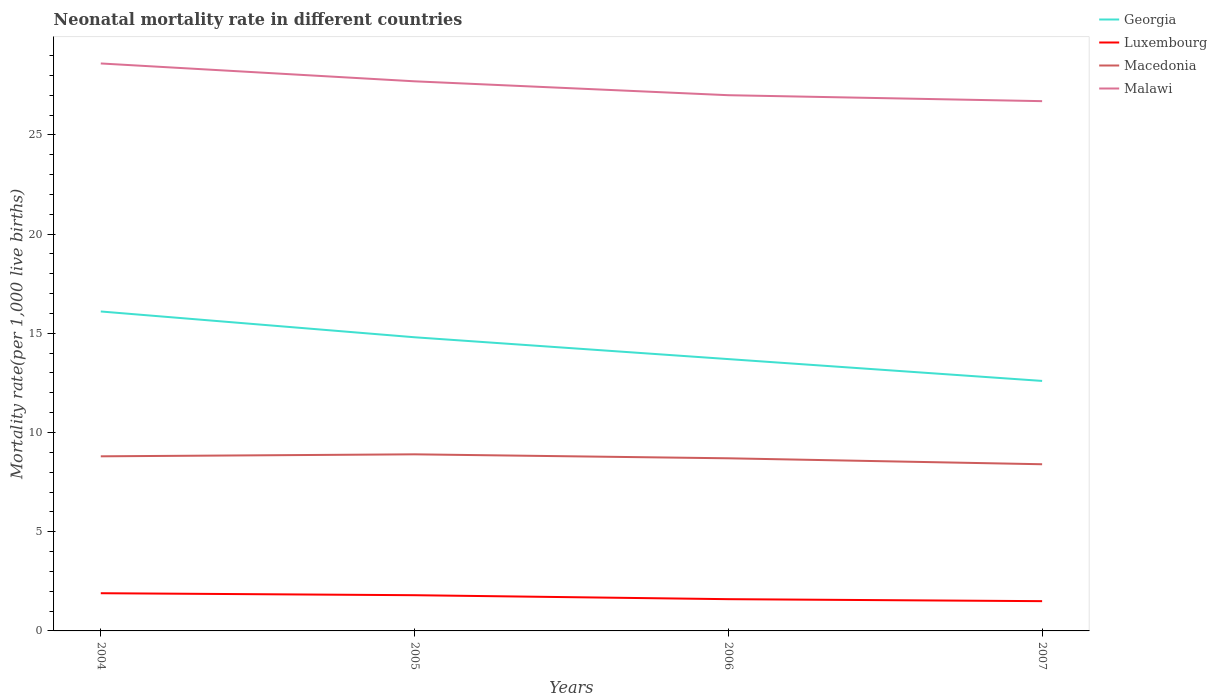Does the line corresponding to Georgia intersect with the line corresponding to Macedonia?
Offer a terse response. No. Across all years, what is the maximum neonatal mortality rate in Macedonia?
Offer a terse response. 8.4. What is the total neonatal mortality rate in Luxembourg in the graph?
Offer a terse response. 0.3. What is the difference between the highest and the second highest neonatal mortality rate in Georgia?
Give a very brief answer. 3.5. Is the neonatal mortality rate in Malawi strictly greater than the neonatal mortality rate in Georgia over the years?
Make the answer very short. No. How many lines are there?
Keep it short and to the point. 4. How many years are there in the graph?
Make the answer very short. 4. What is the difference between two consecutive major ticks on the Y-axis?
Your response must be concise. 5. Are the values on the major ticks of Y-axis written in scientific E-notation?
Your answer should be compact. No. How many legend labels are there?
Your answer should be very brief. 4. How are the legend labels stacked?
Your answer should be compact. Vertical. What is the title of the graph?
Your response must be concise. Neonatal mortality rate in different countries. Does "Rwanda" appear as one of the legend labels in the graph?
Offer a very short reply. No. What is the label or title of the Y-axis?
Your response must be concise. Mortality rate(per 1,0 live births). What is the Mortality rate(per 1,000 live births) in Luxembourg in 2004?
Ensure brevity in your answer.  1.9. What is the Mortality rate(per 1,000 live births) of Macedonia in 2004?
Give a very brief answer. 8.8. What is the Mortality rate(per 1,000 live births) in Malawi in 2004?
Your response must be concise. 28.6. What is the Mortality rate(per 1,000 live births) of Georgia in 2005?
Offer a terse response. 14.8. What is the Mortality rate(per 1,000 live births) in Malawi in 2005?
Keep it short and to the point. 27.7. What is the Mortality rate(per 1,000 live births) of Macedonia in 2006?
Your answer should be very brief. 8.7. What is the Mortality rate(per 1,000 live births) in Luxembourg in 2007?
Your response must be concise. 1.5. What is the Mortality rate(per 1,000 live births) in Macedonia in 2007?
Offer a very short reply. 8.4. What is the Mortality rate(per 1,000 live births) in Malawi in 2007?
Your answer should be very brief. 26.7. Across all years, what is the maximum Mortality rate(per 1,000 live births) in Luxembourg?
Offer a very short reply. 1.9. Across all years, what is the maximum Mortality rate(per 1,000 live births) in Macedonia?
Offer a terse response. 8.9. Across all years, what is the maximum Mortality rate(per 1,000 live births) in Malawi?
Ensure brevity in your answer.  28.6. Across all years, what is the minimum Mortality rate(per 1,000 live births) of Malawi?
Provide a succinct answer. 26.7. What is the total Mortality rate(per 1,000 live births) in Georgia in the graph?
Provide a succinct answer. 57.2. What is the total Mortality rate(per 1,000 live births) in Macedonia in the graph?
Give a very brief answer. 34.8. What is the total Mortality rate(per 1,000 live births) in Malawi in the graph?
Offer a terse response. 110. What is the difference between the Mortality rate(per 1,000 live births) of Luxembourg in 2004 and that in 2005?
Your answer should be compact. 0.1. What is the difference between the Mortality rate(per 1,000 live births) in Macedonia in 2004 and that in 2005?
Offer a terse response. -0.1. What is the difference between the Mortality rate(per 1,000 live births) of Luxembourg in 2004 and that in 2006?
Your answer should be compact. 0.3. What is the difference between the Mortality rate(per 1,000 live births) in Macedonia in 2004 and that in 2006?
Your response must be concise. 0.1. What is the difference between the Mortality rate(per 1,000 live births) of Malawi in 2004 and that in 2006?
Make the answer very short. 1.6. What is the difference between the Mortality rate(per 1,000 live births) of Luxembourg in 2004 and that in 2007?
Your answer should be compact. 0.4. What is the difference between the Mortality rate(per 1,000 live births) of Macedonia in 2004 and that in 2007?
Your response must be concise. 0.4. What is the difference between the Mortality rate(per 1,000 live births) in Malawi in 2004 and that in 2007?
Provide a short and direct response. 1.9. What is the difference between the Mortality rate(per 1,000 live births) of Macedonia in 2005 and that in 2006?
Provide a succinct answer. 0.2. What is the difference between the Mortality rate(per 1,000 live births) of Macedonia in 2005 and that in 2007?
Provide a succinct answer. 0.5. What is the difference between the Mortality rate(per 1,000 live births) of Macedonia in 2006 and that in 2007?
Offer a terse response. 0.3. What is the difference between the Mortality rate(per 1,000 live births) in Georgia in 2004 and the Mortality rate(per 1,000 live births) in Luxembourg in 2005?
Offer a very short reply. 14.3. What is the difference between the Mortality rate(per 1,000 live births) of Georgia in 2004 and the Mortality rate(per 1,000 live births) of Macedonia in 2005?
Provide a succinct answer. 7.2. What is the difference between the Mortality rate(per 1,000 live births) of Luxembourg in 2004 and the Mortality rate(per 1,000 live births) of Macedonia in 2005?
Give a very brief answer. -7. What is the difference between the Mortality rate(per 1,000 live births) in Luxembourg in 2004 and the Mortality rate(per 1,000 live births) in Malawi in 2005?
Offer a terse response. -25.8. What is the difference between the Mortality rate(per 1,000 live births) of Macedonia in 2004 and the Mortality rate(per 1,000 live births) of Malawi in 2005?
Provide a succinct answer. -18.9. What is the difference between the Mortality rate(per 1,000 live births) in Georgia in 2004 and the Mortality rate(per 1,000 live births) in Macedonia in 2006?
Ensure brevity in your answer.  7.4. What is the difference between the Mortality rate(per 1,000 live births) in Georgia in 2004 and the Mortality rate(per 1,000 live births) in Malawi in 2006?
Give a very brief answer. -10.9. What is the difference between the Mortality rate(per 1,000 live births) in Luxembourg in 2004 and the Mortality rate(per 1,000 live births) in Macedonia in 2006?
Your response must be concise. -6.8. What is the difference between the Mortality rate(per 1,000 live births) of Luxembourg in 2004 and the Mortality rate(per 1,000 live births) of Malawi in 2006?
Offer a terse response. -25.1. What is the difference between the Mortality rate(per 1,000 live births) of Macedonia in 2004 and the Mortality rate(per 1,000 live births) of Malawi in 2006?
Your answer should be compact. -18.2. What is the difference between the Mortality rate(per 1,000 live births) in Georgia in 2004 and the Mortality rate(per 1,000 live births) in Macedonia in 2007?
Give a very brief answer. 7.7. What is the difference between the Mortality rate(per 1,000 live births) in Luxembourg in 2004 and the Mortality rate(per 1,000 live births) in Malawi in 2007?
Your answer should be very brief. -24.8. What is the difference between the Mortality rate(per 1,000 live births) of Macedonia in 2004 and the Mortality rate(per 1,000 live births) of Malawi in 2007?
Offer a terse response. -17.9. What is the difference between the Mortality rate(per 1,000 live births) of Georgia in 2005 and the Mortality rate(per 1,000 live births) of Macedonia in 2006?
Offer a very short reply. 6.1. What is the difference between the Mortality rate(per 1,000 live births) of Georgia in 2005 and the Mortality rate(per 1,000 live births) of Malawi in 2006?
Provide a succinct answer. -12.2. What is the difference between the Mortality rate(per 1,000 live births) in Luxembourg in 2005 and the Mortality rate(per 1,000 live births) in Macedonia in 2006?
Your answer should be very brief. -6.9. What is the difference between the Mortality rate(per 1,000 live births) in Luxembourg in 2005 and the Mortality rate(per 1,000 live births) in Malawi in 2006?
Give a very brief answer. -25.2. What is the difference between the Mortality rate(per 1,000 live births) of Macedonia in 2005 and the Mortality rate(per 1,000 live births) of Malawi in 2006?
Provide a short and direct response. -18.1. What is the difference between the Mortality rate(per 1,000 live births) in Georgia in 2005 and the Mortality rate(per 1,000 live births) in Luxembourg in 2007?
Your response must be concise. 13.3. What is the difference between the Mortality rate(per 1,000 live births) of Luxembourg in 2005 and the Mortality rate(per 1,000 live births) of Macedonia in 2007?
Keep it short and to the point. -6.6. What is the difference between the Mortality rate(per 1,000 live births) of Luxembourg in 2005 and the Mortality rate(per 1,000 live births) of Malawi in 2007?
Offer a very short reply. -24.9. What is the difference between the Mortality rate(per 1,000 live births) of Macedonia in 2005 and the Mortality rate(per 1,000 live births) of Malawi in 2007?
Keep it short and to the point. -17.8. What is the difference between the Mortality rate(per 1,000 live births) in Georgia in 2006 and the Mortality rate(per 1,000 live births) in Luxembourg in 2007?
Make the answer very short. 12.2. What is the difference between the Mortality rate(per 1,000 live births) of Georgia in 2006 and the Mortality rate(per 1,000 live births) of Macedonia in 2007?
Provide a succinct answer. 5.3. What is the difference between the Mortality rate(per 1,000 live births) of Georgia in 2006 and the Mortality rate(per 1,000 live births) of Malawi in 2007?
Make the answer very short. -13. What is the difference between the Mortality rate(per 1,000 live births) of Luxembourg in 2006 and the Mortality rate(per 1,000 live births) of Malawi in 2007?
Give a very brief answer. -25.1. What is the difference between the Mortality rate(per 1,000 live births) of Macedonia in 2006 and the Mortality rate(per 1,000 live births) of Malawi in 2007?
Your answer should be very brief. -18. What is the average Mortality rate(per 1,000 live births) of Georgia per year?
Your response must be concise. 14.3. What is the average Mortality rate(per 1,000 live births) of Macedonia per year?
Keep it short and to the point. 8.7. In the year 2004, what is the difference between the Mortality rate(per 1,000 live births) of Georgia and Mortality rate(per 1,000 live births) of Luxembourg?
Keep it short and to the point. 14.2. In the year 2004, what is the difference between the Mortality rate(per 1,000 live births) of Georgia and Mortality rate(per 1,000 live births) of Macedonia?
Your answer should be very brief. 7.3. In the year 2004, what is the difference between the Mortality rate(per 1,000 live births) of Georgia and Mortality rate(per 1,000 live births) of Malawi?
Offer a very short reply. -12.5. In the year 2004, what is the difference between the Mortality rate(per 1,000 live births) in Luxembourg and Mortality rate(per 1,000 live births) in Malawi?
Give a very brief answer. -26.7. In the year 2004, what is the difference between the Mortality rate(per 1,000 live births) of Macedonia and Mortality rate(per 1,000 live births) of Malawi?
Provide a short and direct response. -19.8. In the year 2005, what is the difference between the Mortality rate(per 1,000 live births) in Georgia and Mortality rate(per 1,000 live births) in Macedonia?
Make the answer very short. 5.9. In the year 2005, what is the difference between the Mortality rate(per 1,000 live births) in Luxembourg and Mortality rate(per 1,000 live births) in Malawi?
Make the answer very short. -25.9. In the year 2005, what is the difference between the Mortality rate(per 1,000 live births) in Macedonia and Mortality rate(per 1,000 live births) in Malawi?
Provide a succinct answer. -18.8. In the year 2006, what is the difference between the Mortality rate(per 1,000 live births) of Luxembourg and Mortality rate(per 1,000 live births) of Malawi?
Make the answer very short. -25.4. In the year 2006, what is the difference between the Mortality rate(per 1,000 live births) in Macedonia and Mortality rate(per 1,000 live births) in Malawi?
Give a very brief answer. -18.3. In the year 2007, what is the difference between the Mortality rate(per 1,000 live births) of Georgia and Mortality rate(per 1,000 live births) of Malawi?
Offer a terse response. -14.1. In the year 2007, what is the difference between the Mortality rate(per 1,000 live births) of Luxembourg and Mortality rate(per 1,000 live births) of Malawi?
Offer a very short reply. -25.2. In the year 2007, what is the difference between the Mortality rate(per 1,000 live births) in Macedonia and Mortality rate(per 1,000 live births) in Malawi?
Make the answer very short. -18.3. What is the ratio of the Mortality rate(per 1,000 live births) of Georgia in 2004 to that in 2005?
Offer a very short reply. 1.09. What is the ratio of the Mortality rate(per 1,000 live births) of Luxembourg in 2004 to that in 2005?
Your answer should be compact. 1.06. What is the ratio of the Mortality rate(per 1,000 live births) of Malawi in 2004 to that in 2005?
Provide a short and direct response. 1.03. What is the ratio of the Mortality rate(per 1,000 live births) of Georgia in 2004 to that in 2006?
Your response must be concise. 1.18. What is the ratio of the Mortality rate(per 1,000 live births) in Luxembourg in 2004 to that in 2006?
Keep it short and to the point. 1.19. What is the ratio of the Mortality rate(per 1,000 live births) of Macedonia in 2004 to that in 2006?
Offer a terse response. 1.01. What is the ratio of the Mortality rate(per 1,000 live births) in Malawi in 2004 to that in 2006?
Give a very brief answer. 1.06. What is the ratio of the Mortality rate(per 1,000 live births) in Georgia in 2004 to that in 2007?
Your answer should be very brief. 1.28. What is the ratio of the Mortality rate(per 1,000 live births) in Luxembourg in 2004 to that in 2007?
Your answer should be very brief. 1.27. What is the ratio of the Mortality rate(per 1,000 live births) in Macedonia in 2004 to that in 2007?
Keep it short and to the point. 1.05. What is the ratio of the Mortality rate(per 1,000 live births) in Malawi in 2004 to that in 2007?
Offer a terse response. 1.07. What is the ratio of the Mortality rate(per 1,000 live births) of Georgia in 2005 to that in 2006?
Offer a very short reply. 1.08. What is the ratio of the Mortality rate(per 1,000 live births) in Luxembourg in 2005 to that in 2006?
Ensure brevity in your answer.  1.12. What is the ratio of the Mortality rate(per 1,000 live births) in Macedonia in 2005 to that in 2006?
Keep it short and to the point. 1.02. What is the ratio of the Mortality rate(per 1,000 live births) in Malawi in 2005 to that in 2006?
Ensure brevity in your answer.  1.03. What is the ratio of the Mortality rate(per 1,000 live births) of Georgia in 2005 to that in 2007?
Your answer should be very brief. 1.17. What is the ratio of the Mortality rate(per 1,000 live births) of Luxembourg in 2005 to that in 2007?
Your response must be concise. 1.2. What is the ratio of the Mortality rate(per 1,000 live births) in Macedonia in 2005 to that in 2007?
Provide a short and direct response. 1.06. What is the ratio of the Mortality rate(per 1,000 live births) in Malawi in 2005 to that in 2007?
Keep it short and to the point. 1.04. What is the ratio of the Mortality rate(per 1,000 live births) of Georgia in 2006 to that in 2007?
Make the answer very short. 1.09. What is the ratio of the Mortality rate(per 1,000 live births) of Luxembourg in 2006 to that in 2007?
Provide a short and direct response. 1.07. What is the ratio of the Mortality rate(per 1,000 live births) of Macedonia in 2006 to that in 2007?
Ensure brevity in your answer.  1.04. What is the ratio of the Mortality rate(per 1,000 live births) of Malawi in 2006 to that in 2007?
Give a very brief answer. 1.01. What is the difference between the highest and the second highest Mortality rate(per 1,000 live births) in Malawi?
Provide a succinct answer. 0.9. What is the difference between the highest and the lowest Mortality rate(per 1,000 live births) of Georgia?
Offer a terse response. 3.5. What is the difference between the highest and the lowest Mortality rate(per 1,000 live births) of Luxembourg?
Keep it short and to the point. 0.4. 